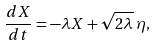Convert formula to latex. <formula><loc_0><loc_0><loc_500><loc_500>\frac { d X } { d t } = - \lambda X + \sqrt { 2 \lambda } \, \eta ,</formula> 